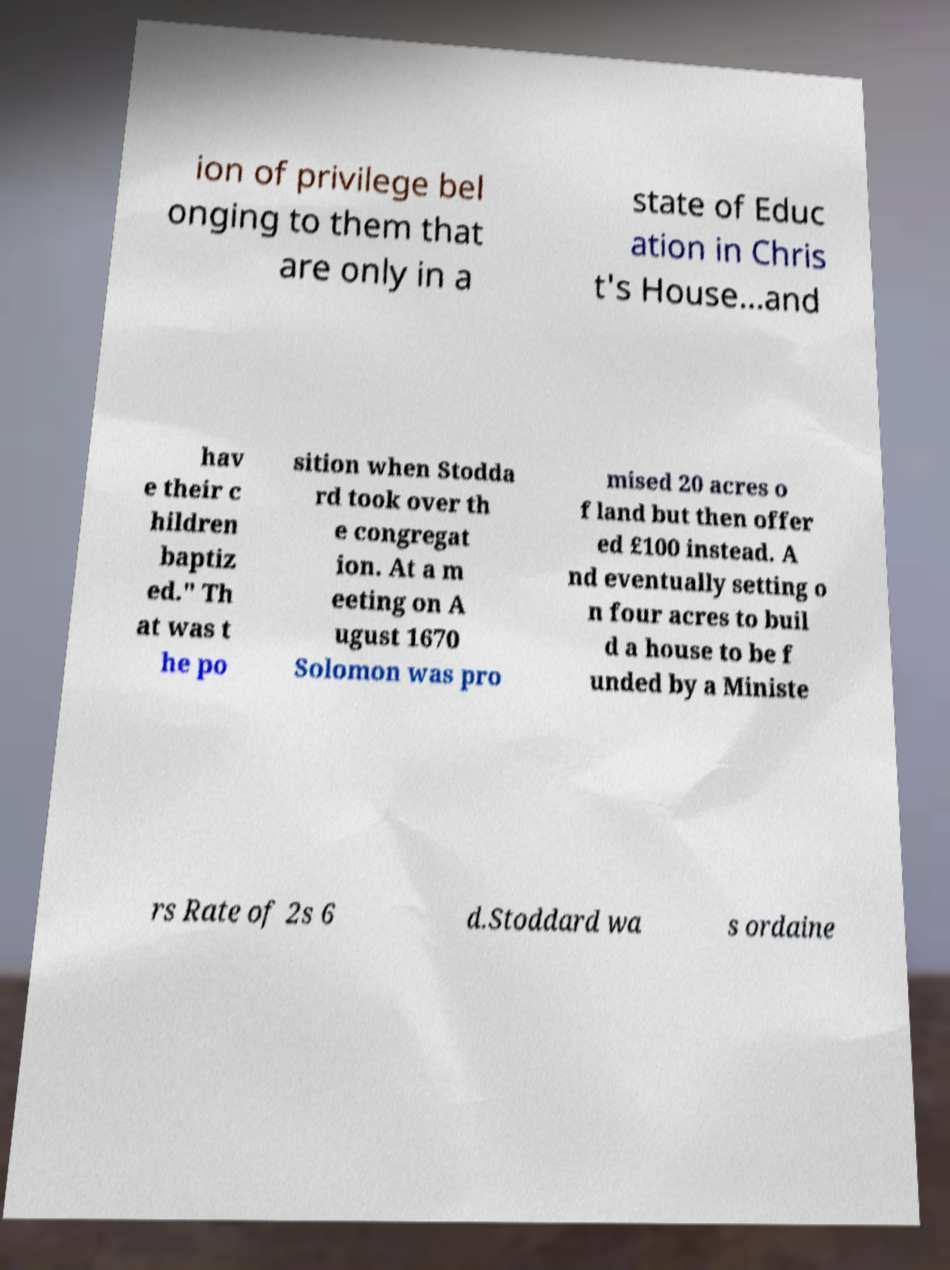Could you extract and type out the text from this image? ion of privilege bel onging to them that are only in a state of Educ ation in Chris t's House...and hav e their c hildren baptiz ed." Th at was t he po sition when Stodda rd took over th e congregat ion. At a m eeting on A ugust 1670 Solomon was pro mised 20 acres o f land but then offer ed £100 instead. A nd eventually setting o n four acres to buil d a house to be f unded by a Ministe rs Rate of 2s 6 d.Stoddard wa s ordaine 